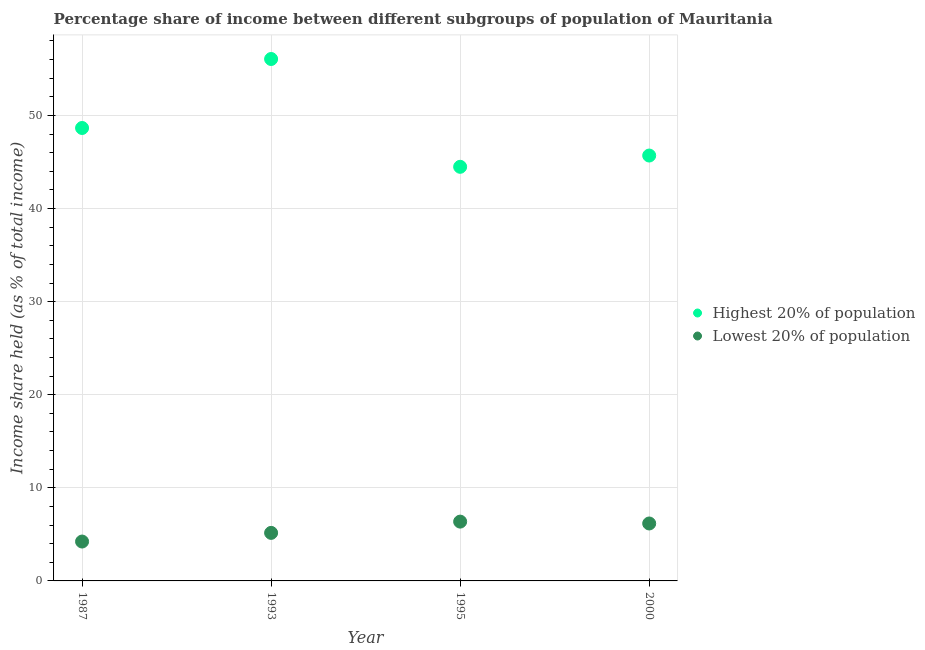What is the income share held by lowest 20% of the population in 1987?
Provide a short and direct response. 4.23. Across all years, what is the maximum income share held by highest 20% of the population?
Your response must be concise. 56.06. Across all years, what is the minimum income share held by highest 20% of the population?
Ensure brevity in your answer.  44.48. In which year was the income share held by highest 20% of the population maximum?
Keep it short and to the point. 1993. In which year was the income share held by highest 20% of the population minimum?
Your answer should be very brief. 1995. What is the total income share held by lowest 20% of the population in the graph?
Offer a very short reply. 21.93. What is the difference between the income share held by lowest 20% of the population in 1987 and that in 2000?
Make the answer very short. -1.94. What is the difference between the income share held by lowest 20% of the population in 1993 and the income share held by highest 20% of the population in 2000?
Your response must be concise. -40.53. What is the average income share held by highest 20% of the population per year?
Make the answer very short. 48.72. In the year 1995, what is the difference between the income share held by highest 20% of the population and income share held by lowest 20% of the population?
Provide a succinct answer. 38.11. In how many years, is the income share held by highest 20% of the population greater than 54 %?
Provide a short and direct response. 1. What is the ratio of the income share held by lowest 20% of the population in 1987 to that in 1993?
Offer a very short reply. 0.82. What is the difference between the highest and the second highest income share held by lowest 20% of the population?
Your response must be concise. 0.2. What is the difference between the highest and the lowest income share held by lowest 20% of the population?
Ensure brevity in your answer.  2.14. In how many years, is the income share held by lowest 20% of the population greater than the average income share held by lowest 20% of the population taken over all years?
Make the answer very short. 2. Is the sum of the income share held by lowest 20% of the population in 1987 and 1993 greater than the maximum income share held by highest 20% of the population across all years?
Your answer should be very brief. No. Is the income share held by lowest 20% of the population strictly greater than the income share held by highest 20% of the population over the years?
Keep it short and to the point. No. Is the income share held by lowest 20% of the population strictly less than the income share held by highest 20% of the population over the years?
Offer a very short reply. Yes. How many dotlines are there?
Ensure brevity in your answer.  2. How many years are there in the graph?
Offer a terse response. 4. What is the difference between two consecutive major ticks on the Y-axis?
Provide a short and direct response. 10. Are the values on the major ticks of Y-axis written in scientific E-notation?
Give a very brief answer. No. Does the graph contain any zero values?
Offer a terse response. No. What is the title of the graph?
Offer a very short reply. Percentage share of income between different subgroups of population of Mauritania. Does "Secondary school" appear as one of the legend labels in the graph?
Offer a very short reply. No. What is the label or title of the X-axis?
Offer a terse response. Year. What is the label or title of the Y-axis?
Your response must be concise. Income share held (as % of total income). What is the Income share held (as % of total income) in Highest 20% of population in 1987?
Your answer should be very brief. 48.65. What is the Income share held (as % of total income) in Lowest 20% of population in 1987?
Ensure brevity in your answer.  4.23. What is the Income share held (as % of total income) in Highest 20% of population in 1993?
Provide a succinct answer. 56.06. What is the Income share held (as % of total income) in Lowest 20% of population in 1993?
Provide a short and direct response. 5.16. What is the Income share held (as % of total income) in Highest 20% of population in 1995?
Ensure brevity in your answer.  44.48. What is the Income share held (as % of total income) in Lowest 20% of population in 1995?
Ensure brevity in your answer.  6.37. What is the Income share held (as % of total income) in Highest 20% of population in 2000?
Make the answer very short. 45.69. What is the Income share held (as % of total income) of Lowest 20% of population in 2000?
Your answer should be very brief. 6.17. Across all years, what is the maximum Income share held (as % of total income) in Highest 20% of population?
Provide a succinct answer. 56.06. Across all years, what is the maximum Income share held (as % of total income) in Lowest 20% of population?
Your answer should be very brief. 6.37. Across all years, what is the minimum Income share held (as % of total income) of Highest 20% of population?
Offer a very short reply. 44.48. Across all years, what is the minimum Income share held (as % of total income) in Lowest 20% of population?
Keep it short and to the point. 4.23. What is the total Income share held (as % of total income) in Highest 20% of population in the graph?
Provide a short and direct response. 194.88. What is the total Income share held (as % of total income) in Lowest 20% of population in the graph?
Keep it short and to the point. 21.93. What is the difference between the Income share held (as % of total income) of Highest 20% of population in 1987 and that in 1993?
Your response must be concise. -7.41. What is the difference between the Income share held (as % of total income) in Lowest 20% of population in 1987 and that in 1993?
Offer a very short reply. -0.93. What is the difference between the Income share held (as % of total income) in Highest 20% of population in 1987 and that in 1995?
Your answer should be very brief. 4.17. What is the difference between the Income share held (as % of total income) of Lowest 20% of population in 1987 and that in 1995?
Ensure brevity in your answer.  -2.14. What is the difference between the Income share held (as % of total income) of Highest 20% of population in 1987 and that in 2000?
Provide a short and direct response. 2.96. What is the difference between the Income share held (as % of total income) of Lowest 20% of population in 1987 and that in 2000?
Your answer should be very brief. -1.94. What is the difference between the Income share held (as % of total income) of Highest 20% of population in 1993 and that in 1995?
Offer a terse response. 11.58. What is the difference between the Income share held (as % of total income) of Lowest 20% of population in 1993 and that in 1995?
Your answer should be compact. -1.21. What is the difference between the Income share held (as % of total income) in Highest 20% of population in 1993 and that in 2000?
Make the answer very short. 10.37. What is the difference between the Income share held (as % of total income) in Lowest 20% of population in 1993 and that in 2000?
Provide a succinct answer. -1.01. What is the difference between the Income share held (as % of total income) in Highest 20% of population in 1995 and that in 2000?
Give a very brief answer. -1.21. What is the difference between the Income share held (as % of total income) in Lowest 20% of population in 1995 and that in 2000?
Ensure brevity in your answer.  0.2. What is the difference between the Income share held (as % of total income) in Highest 20% of population in 1987 and the Income share held (as % of total income) in Lowest 20% of population in 1993?
Make the answer very short. 43.49. What is the difference between the Income share held (as % of total income) of Highest 20% of population in 1987 and the Income share held (as % of total income) of Lowest 20% of population in 1995?
Provide a short and direct response. 42.28. What is the difference between the Income share held (as % of total income) in Highest 20% of population in 1987 and the Income share held (as % of total income) in Lowest 20% of population in 2000?
Give a very brief answer. 42.48. What is the difference between the Income share held (as % of total income) in Highest 20% of population in 1993 and the Income share held (as % of total income) in Lowest 20% of population in 1995?
Make the answer very short. 49.69. What is the difference between the Income share held (as % of total income) of Highest 20% of population in 1993 and the Income share held (as % of total income) of Lowest 20% of population in 2000?
Your response must be concise. 49.89. What is the difference between the Income share held (as % of total income) of Highest 20% of population in 1995 and the Income share held (as % of total income) of Lowest 20% of population in 2000?
Your response must be concise. 38.31. What is the average Income share held (as % of total income) in Highest 20% of population per year?
Provide a succinct answer. 48.72. What is the average Income share held (as % of total income) in Lowest 20% of population per year?
Your answer should be very brief. 5.48. In the year 1987, what is the difference between the Income share held (as % of total income) of Highest 20% of population and Income share held (as % of total income) of Lowest 20% of population?
Your response must be concise. 44.42. In the year 1993, what is the difference between the Income share held (as % of total income) in Highest 20% of population and Income share held (as % of total income) in Lowest 20% of population?
Offer a terse response. 50.9. In the year 1995, what is the difference between the Income share held (as % of total income) of Highest 20% of population and Income share held (as % of total income) of Lowest 20% of population?
Your answer should be compact. 38.11. In the year 2000, what is the difference between the Income share held (as % of total income) of Highest 20% of population and Income share held (as % of total income) of Lowest 20% of population?
Your answer should be compact. 39.52. What is the ratio of the Income share held (as % of total income) of Highest 20% of population in 1987 to that in 1993?
Offer a very short reply. 0.87. What is the ratio of the Income share held (as % of total income) in Lowest 20% of population in 1987 to that in 1993?
Offer a terse response. 0.82. What is the ratio of the Income share held (as % of total income) of Highest 20% of population in 1987 to that in 1995?
Your answer should be compact. 1.09. What is the ratio of the Income share held (as % of total income) of Lowest 20% of population in 1987 to that in 1995?
Ensure brevity in your answer.  0.66. What is the ratio of the Income share held (as % of total income) in Highest 20% of population in 1987 to that in 2000?
Your answer should be very brief. 1.06. What is the ratio of the Income share held (as % of total income) in Lowest 20% of population in 1987 to that in 2000?
Offer a terse response. 0.69. What is the ratio of the Income share held (as % of total income) of Highest 20% of population in 1993 to that in 1995?
Ensure brevity in your answer.  1.26. What is the ratio of the Income share held (as % of total income) of Lowest 20% of population in 1993 to that in 1995?
Give a very brief answer. 0.81. What is the ratio of the Income share held (as % of total income) of Highest 20% of population in 1993 to that in 2000?
Your answer should be compact. 1.23. What is the ratio of the Income share held (as % of total income) in Lowest 20% of population in 1993 to that in 2000?
Your response must be concise. 0.84. What is the ratio of the Income share held (as % of total income) in Highest 20% of population in 1995 to that in 2000?
Your answer should be compact. 0.97. What is the ratio of the Income share held (as % of total income) of Lowest 20% of population in 1995 to that in 2000?
Your answer should be very brief. 1.03. What is the difference between the highest and the second highest Income share held (as % of total income) in Highest 20% of population?
Your answer should be compact. 7.41. What is the difference between the highest and the lowest Income share held (as % of total income) of Highest 20% of population?
Ensure brevity in your answer.  11.58. What is the difference between the highest and the lowest Income share held (as % of total income) of Lowest 20% of population?
Give a very brief answer. 2.14. 